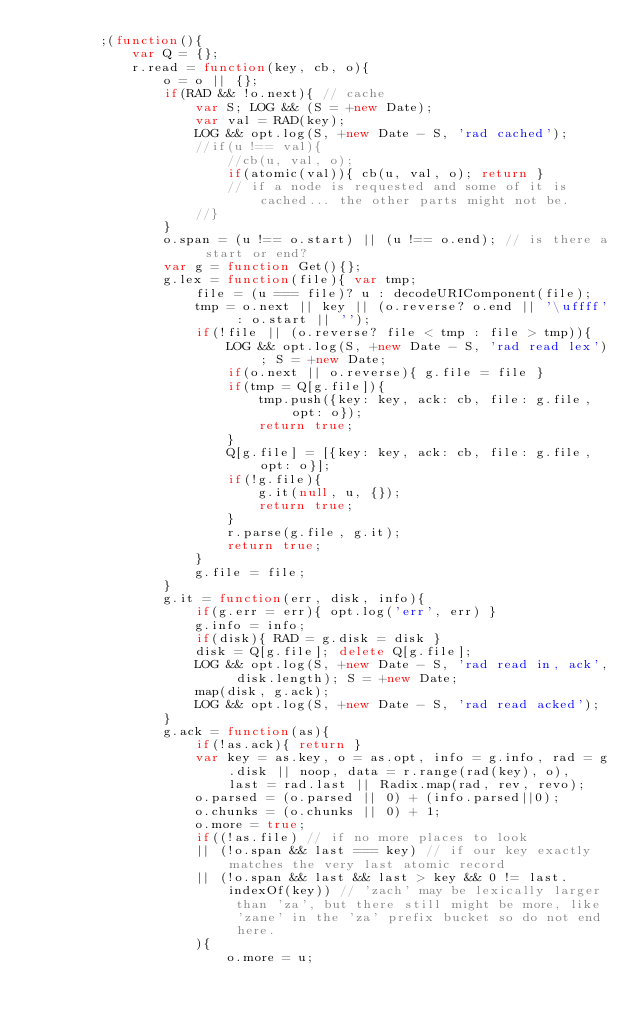Convert code to text. <code><loc_0><loc_0><loc_500><loc_500><_JavaScript_>		;(function(){
			var Q = {};
			r.read = function(key, cb, o){
				o = o || {};
				if(RAD && !o.next){ // cache
					var S; LOG && (S = +new Date);
					var val = RAD(key);
					LOG && opt.log(S, +new Date - S, 'rad cached');
					//if(u !== val){
						//cb(u, val, o);
						if(atomic(val)){ cb(u, val, o); return }
						// if a node is requested and some of it is cached... the other parts might not be.
					//}
				}
				o.span = (u !== o.start) || (u !== o.end); // is there a start or end?
				var g = function Get(){};
				g.lex = function(file){ var tmp;
					file = (u === file)? u : decodeURIComponent(file);
					tmp = o.next || key || (o.reverse? o.end || '\uffff' : o.start || '');
					if(!file || (o.reverse? file < tmp : file > tmp)){
						LOG && opt.log(S, +new Date - S, 'rad read lex'); S = +new Date;
						if(o.next || o.reverse){ g.file = file }
						if(tmp = Q[g.file]){
							tmp.push({key: key, ack: cb, file: g.file, opt: o});
							return true;
						}
						Q[g.file] = [{key: key, ack: cb, file: g.file, opt: o}];
						if(!g.file){
							g.it(null, u, {});
							return true; 
						}
						r.parse(g.file, g.it);
						return true;
					}
					g.file = file;
				}
				g.it = function(err, disk, info){
					if(g.err = err){ opt.log('err', err) }
					g.info = info;
					if(disk){ RAD = g.disk = disk }
					disk = Q[g.file]; delete Q[g.file];
					LOG && opt.log(S, +new Date - S, 'rad read in, ack', disk.length); S = +new Date;
					map(disk, g.ack);
					LOG && opt.log(S, +new Date - S, 'rad read acked');
				}
				g.ack = function(as){
					if(!as.ack){ return }
					var key = as.key, o = as.opt, info = g.info, rad = g.disk || noop, data = r.range(rad(key), o), last = rad.last || Radix.map(rad, rev, revo);
					o.parsed = (o.parsed || 0) + (info.parsed||0);
					o.chunks = (o.chunks || 0) + 1;
					o.more = true;
					if((!as.file) // if no more places to look
					|| (!o.span && last === key) // if our key exactly matches the very last atomic record
					|| (!o.span && last && last > key && 0 != last.indexOf(key)) // 'zach' may be lexically larger than 'za', but there still might be more, like 'zane' in the 'za' prefix bucket so do not end here.
					){
						o.more = u;</code> 